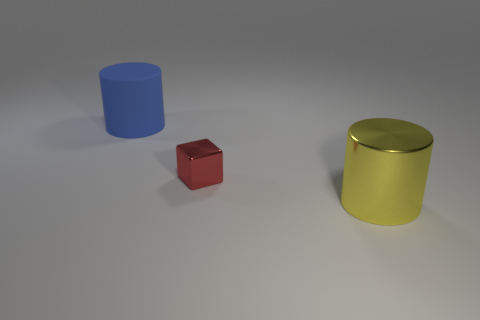Are there any other things that are made of the same material as the blue object?
Give a very brief answer. No. What size is the yellow shiny object?
Keep it short and to the point. Large. Does the big matte object have the same shape as the thing right of the red metallic thing?
Keep it short and to the point. Yes. What is the color of the big thing that is made of the same material as the tiny red cube?
Provide a succinct answer. Yellow. There is a object in front of the small block; what is its size?
Provide a short and direct response. Large. Is the number of small cubes that are in front of the big yellow cylinder less than the number of blue rubber things?
Give a very brief answer. Yes. Do the small thing and the big shiny thing have the same color?
Provide a succinct answer. No. Is there any other thing that has the same shape as the big rubber thing?
Keep it short and to the point. Yes. Are there fewer blue cylinders than gray metal objects?
Your answer should be compact. No. The metallic object in front of the metallic object that is to the left of the yellow thing is what color?
Your answer should be very brief. Yellow. 